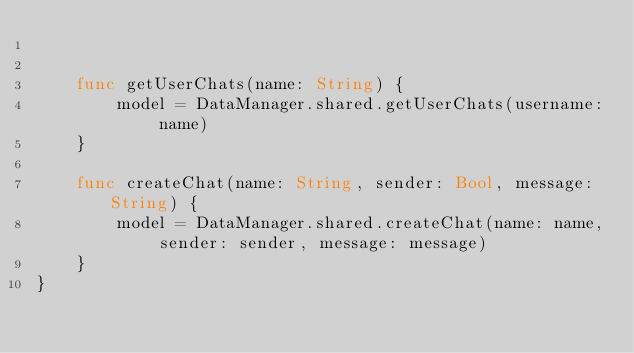<code> <loc_0><loc_0><loc_500><loc_500><_Swift_>    
    
    func getUserChats(name: String) {
        model = DataManager.shared.getUserChats(username: name)
    }
    
    func createChat(name: String, sender: Bool, message: String) {
        model = DataManager.shared.createChat(name: name, sender: sender, message: message)
    }
}
</code> 